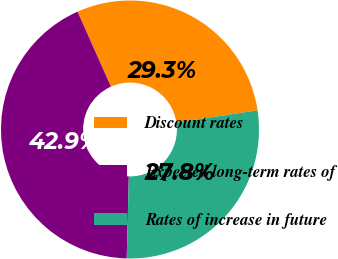Convert chart to OTSL. <chart><loc_0><loc_0><loc_500><loc_500><pie_chart><fcel>Discount rates<fcel>Expected long-term rates of<fcel>Rates of increase in future<nl><fcel>29.29%<fcel>42.93%<fcel>27.78%<nl></chart> 